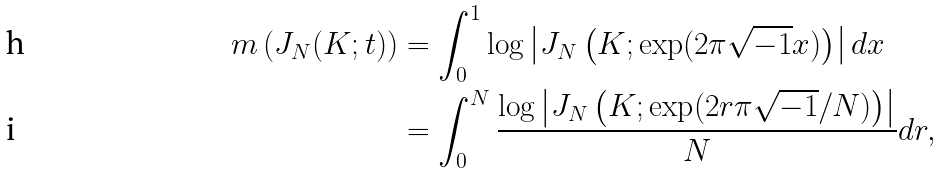Convert formula to latex. <formula><loc_0><loc_0><loc_500><loc_500>m \left ( J _ { N } ( K ; t ) \right ) & = \int _ { 0 } ^ { 1 } \log \left | J _ { N } \left ( K ; \exp ( 2 \pi \sqrt { - 1 } x ) \right ) \right | d x \\ & = \int _ { 0 } ^ { N } \frac { \log \left | J _ { N } \left ( K ; \exp ( 2 r \pi \sqrt { - 1 } / N ) \right ) \right | } { N } d r ,</formula> 